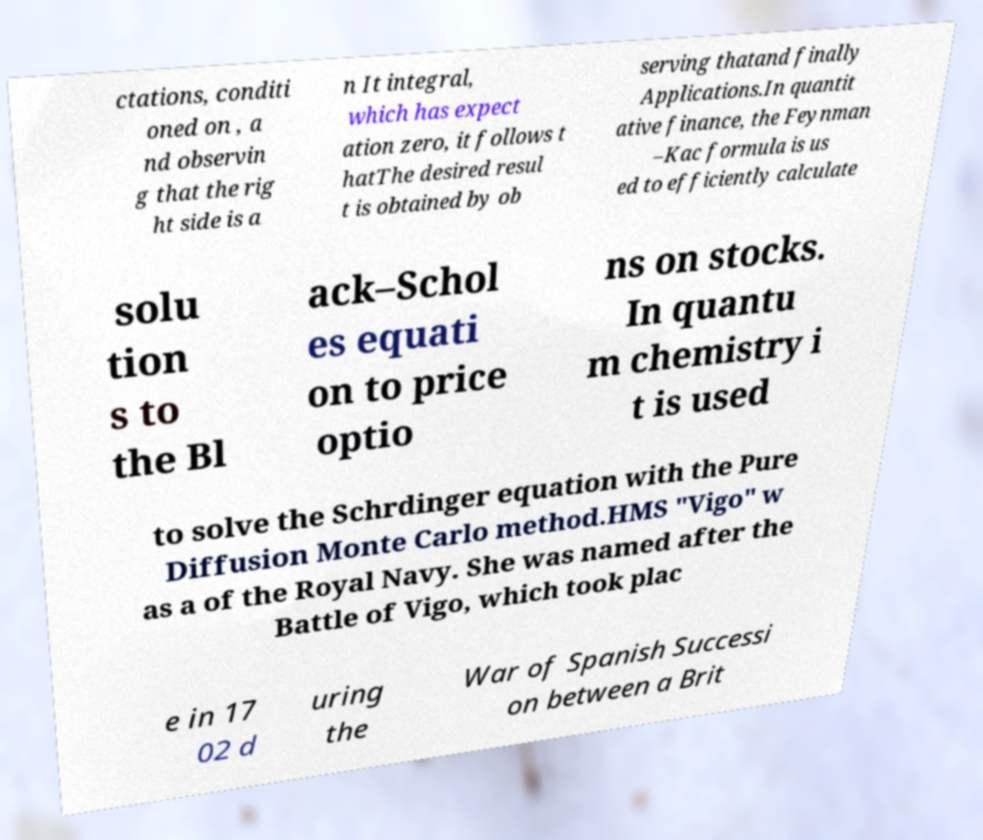For documentation purposes, I need the text within this image transcribed. Could you provide that? ctations, conditi oned on , a nd observin g that the rig ht side is a n It integral, which has expect ation zero, it follows t hatThe desired resul t is obtained by ob serving thatand finally Applications.In quantit ative finance, the Feynman –Kac formula is us ed to efficiently calculate solu tion s to the Bl ack–Schol es equati on to price optio ns on stocks. In quantu m chemistry i t is used to solve the Schrdinger equation with the Pure Diffusion Monte Carlo method.HMS "Vigo" w as a of the Royal Navy. She was named after the Battle of Vigo, which took plac e in 17 02 d uring the War of Spanish Successi on between a Brit 